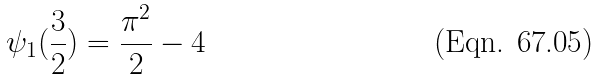Convert formula to latex. <formula><loc_0><loc_0><loc_500><loc_500>\psi _ { 1 } ( \frac { 3 } { 2 } ) = \frac { \pi ^ { 2 } } { 2 } - 4</formula> 